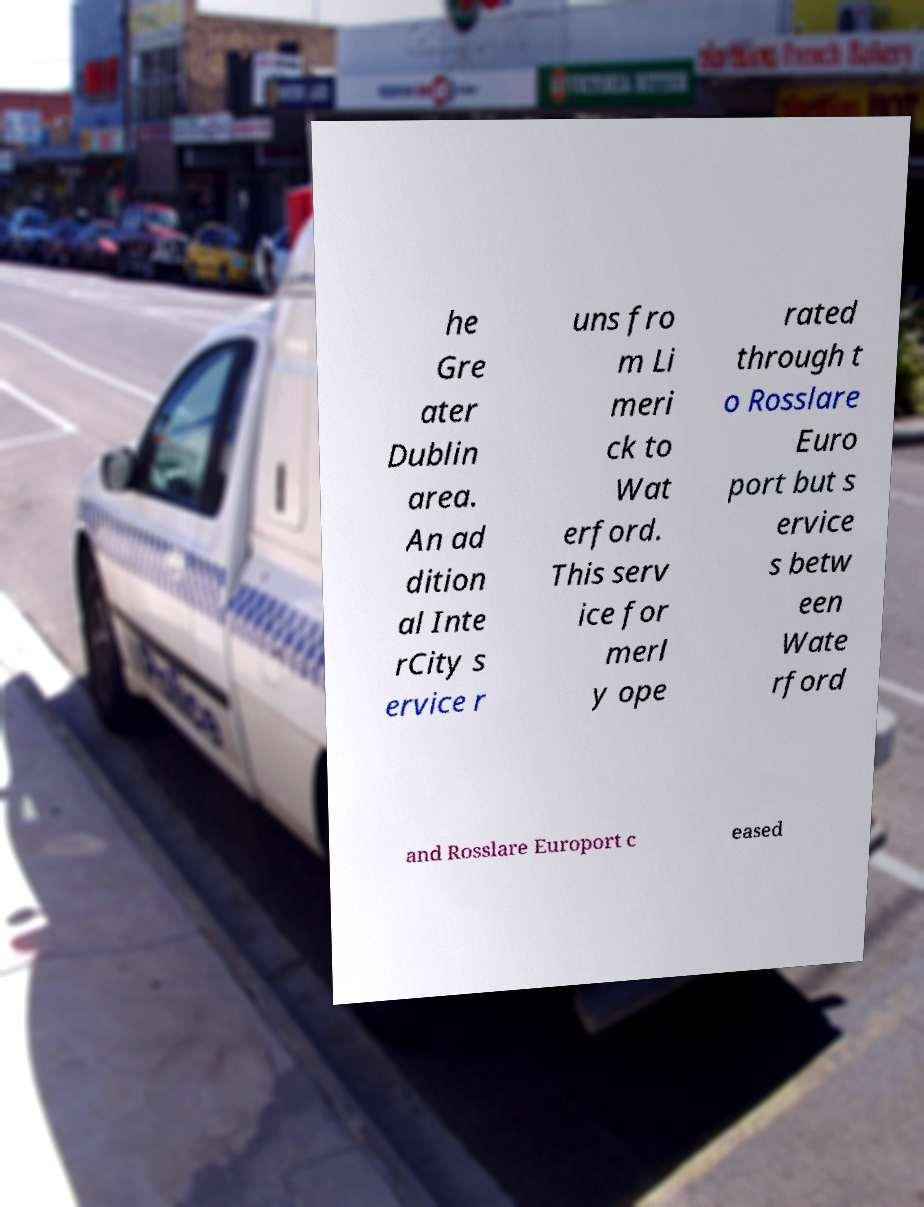Can you accurately transcribe the text from the provided image for me? he Gre ater Dublin area. An ad dition al Inte rCity s ervice r uns fro m Li meri ck to Wat erford. This serv ice for merl y ope rated through t o Rosslare Euro port but s ervice s betw een Wate rford and Rosslare Europort c eased 